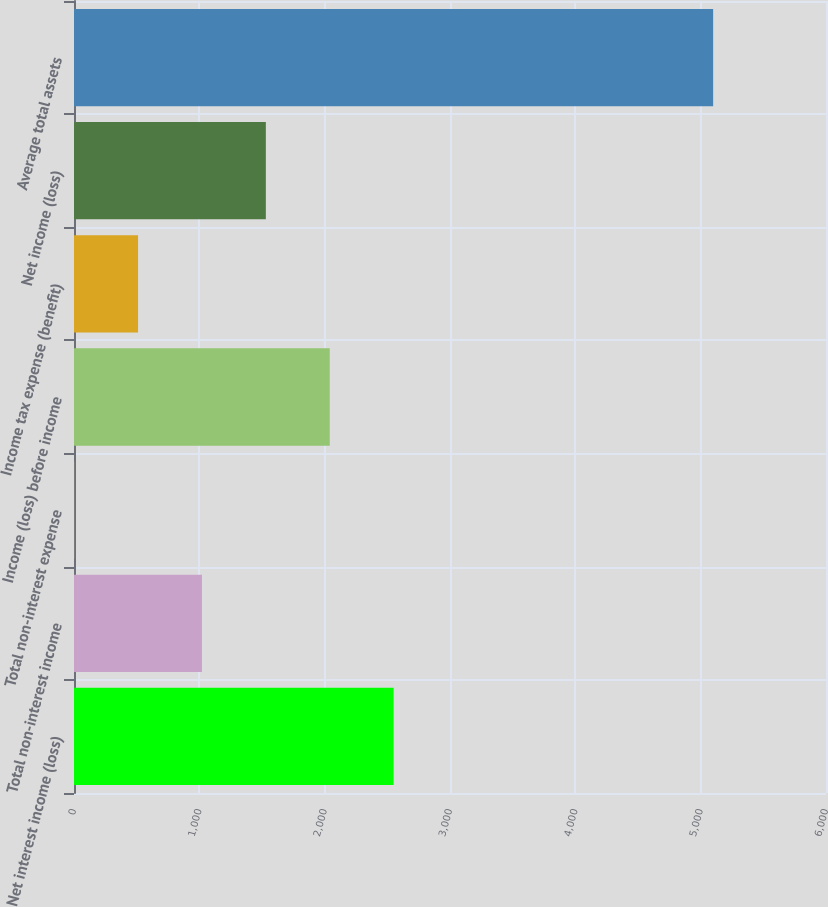Convert chart. <chart><loc_0><loc_0><loc_500><loc_500><bar_chart><fcel>Net interest income (loss)<fcel>Total non-interest income<fcel>Total non-interest expense<fcel>Income (loss) before income<fcel>Income tax expense (benefit)<fcel>Net income (loss)<fcel>Average total assets<nl><fcel>2550.35<fcel>1020.86<fcel>1.2<fcel>2040.52<fcel>511.03<fcel>1530.69<fcel>5099.5<nl></chart> 